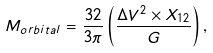<formula> <loc_0><loc_0><loc_500><loc_500>M _ { o r b i t a l } = \frac { 3 2 } { 3 \pi } \left ( \frac { \Delta V ^ { 2 } \times X _ { 1 2 } } { G } \right ) ,</formula> 